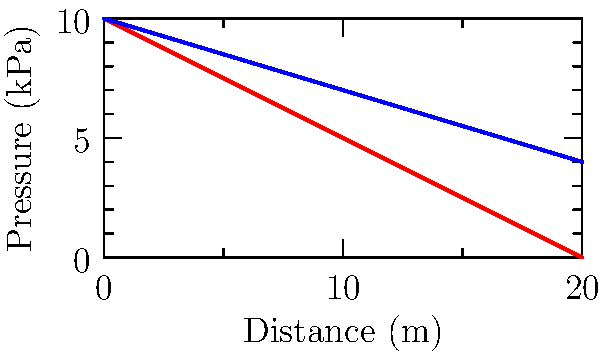The graph above shows the water pressure distribution in two aqueducts, one using Roman engineering techniques (red) and the other using Catalan techniques (blue). Both start with an initial pressure of 10 kPa. If the Catalan aqueduct maintains its pressure 5 kPa higher than the Roman aqueduct at a distance of 10 meters, what is the rate of pressure loss (in kPa/m) for the Catalan aqueduct? To solve this problem, we need to follow these steps:

1. Identify the pressure loss rate for the Roman aqueduct:
   From the graph, we can see that the Roman line decreases at a rate of 0.5 kPa/m.

2. Calculate the pressure in the Roman aqueduct at 10 meters:
   $$P_{Roman} = 10 - (0.5 * 10) = 5 \text{ kPa}$$

3. Calculate the pressure in the Catalan aqueduct at 10 meters:
   Given that it's 5 kPa higher than the Roman aqueduct:
   $$P_{Catalan} = 5 + 5 = 10 \text{ kPa}$$

4. Calculate the total pressure loss in the Catalan aqueduct over 10 meters:
   $$\text{Pressure loss} = 10 - 10 = 0 \text{ kPa}$$

5. Calculate the rate of pressure loss for the Catalan aqueduct:
   $$\text{Rate} = \frac{\text{Pressure loss}}{\text{Distance}} = \frac{0 \text{ kPa}}{10 \text{ m}} = 0 \text{ kPa/m}$$

Therefore, the Catalan aqueduct maintains its pressure without any loss over the 10-meter distance.
Answer: 0 kPa/m 